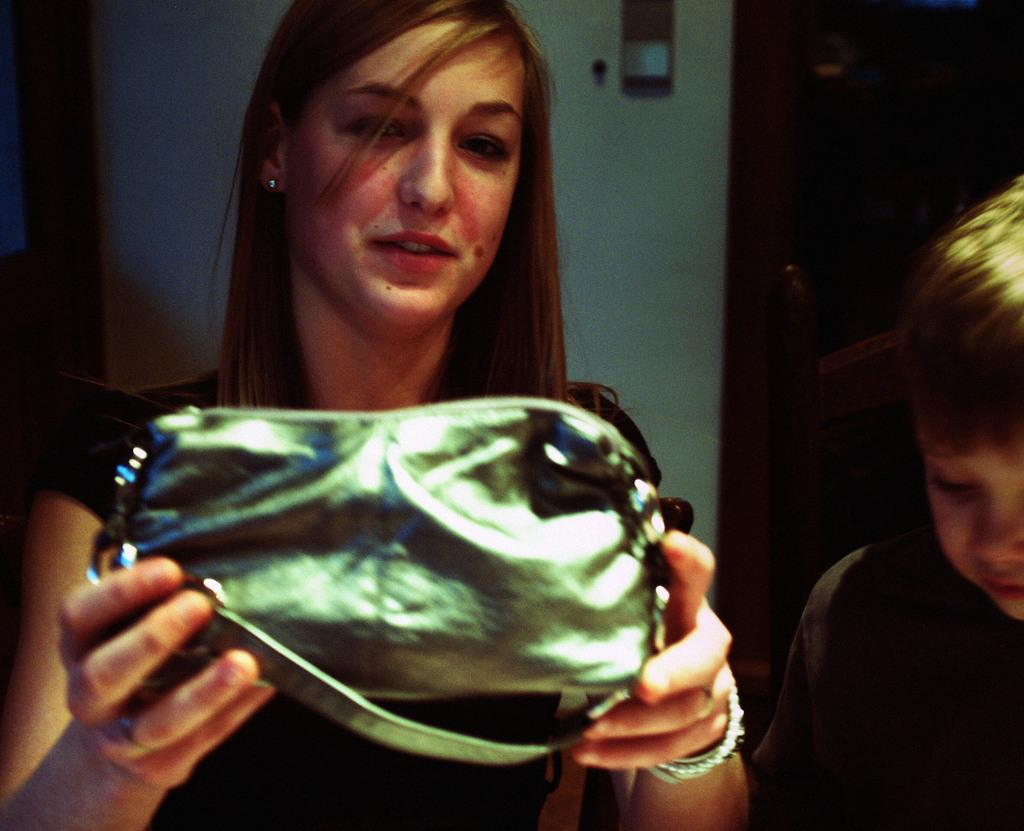Who is the main subject in the image? There is a woman in the image. What is the woman doing in the image? The woman is standing in the image. What is the woman holding in the image? The woman is holding a purse in the image. Who else is present in the image besides the woman? There is a boy in the image. What is the boy doing in the image? The boy is standing beside the woman in the image. What type of prose can be heard in the background of the image? There is no prose or sound present in the image, as it is a still photograph. 